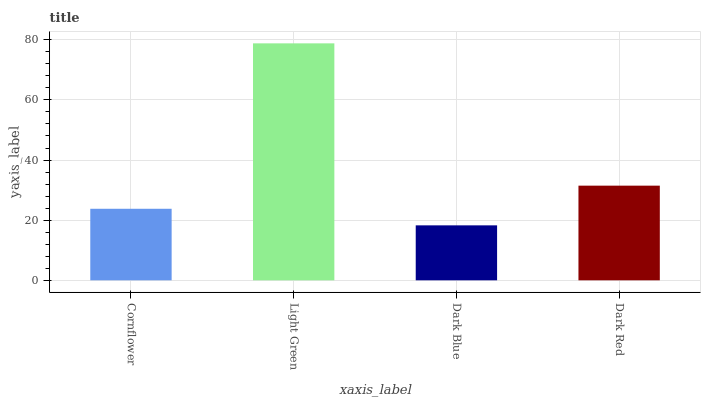Is Dark Blue the minimum?
Answer yes or no. Yes. Is Light Green the maximum?
Answer yes or no. Yes. Is Light Green the minimum?
Answer yes or no. No. Is Dark Blue the maximum?
Answer yes or no. No. Is Light Green greater than Dark Blue?
Answer yes or no. Yes. Is Dark Blue less than Light Green?
Answer yes or no. Yes. Is Dark Blue greater than Light Green?
Answer yes or no. No. Is Light Green less than Dark Blue?
Answer yes or no. No. Is Dark Red the high median?
Answer yes or no. Yes. Is Cornflower the low median?
Answer yes or no. Yes. Is Light Green the high median?
Answer yes or no. No. Is Light Green the low median?
Answer yes or no. No. 